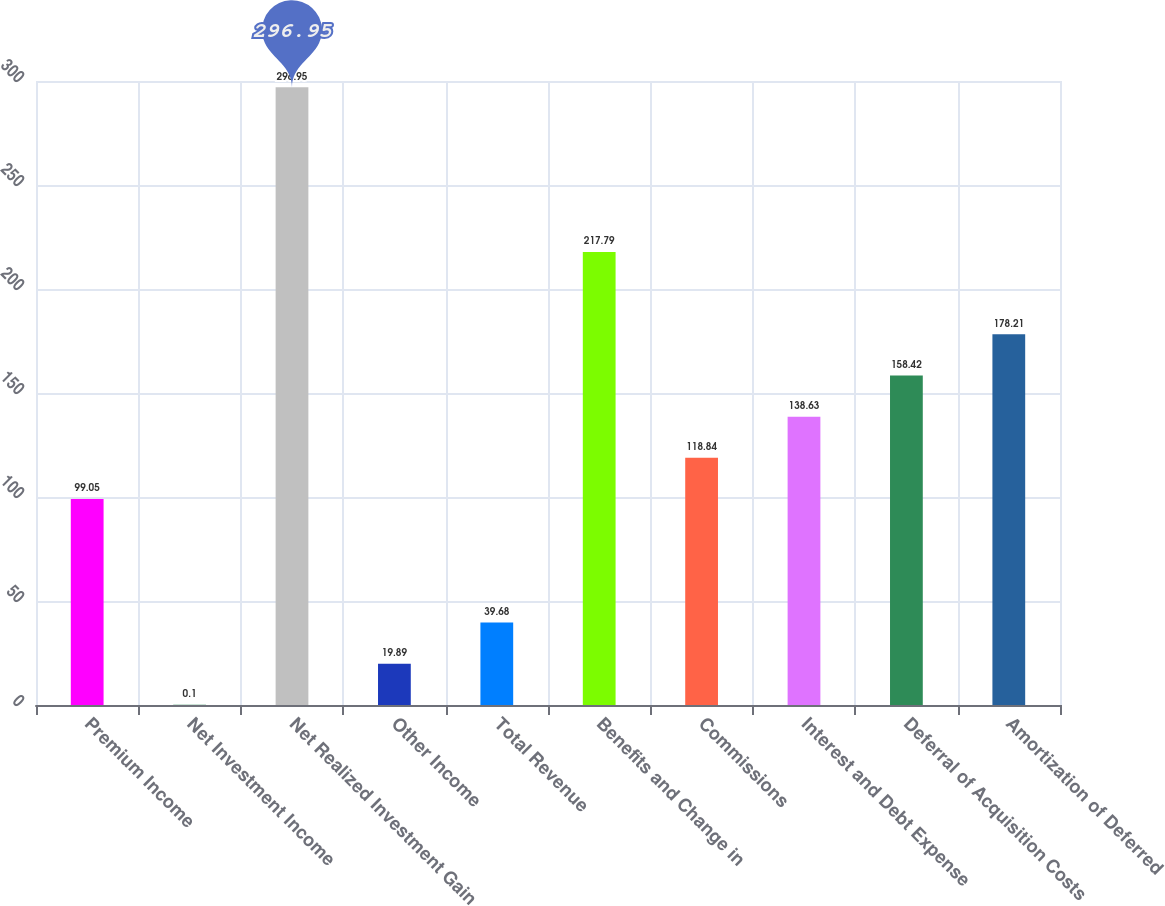Convert chart to OTSL. <chart><loc_0><loc_0><loc_500><loc_500><bar_chart><fcel>Premium Income<fcel>Net Investment Income<fcel>Net Realized Investment Gain<fcel>Other Income<fcel>Total Revenue<fcel>Benefits and Change in<fcel>Commissions<fcel>Interest and Debt Expense<fcel>Deferral of Acquisition Costs<fcel>Amortization of Deferred<nl><fcel>99.05<fcel>0.1<fcel>296.95<fcel>19.89<fcel>39.68<fcel>217.79<fcel>118.84<fcel>138.63<fcel>158.42<fcel>178.21<nl></chart> 